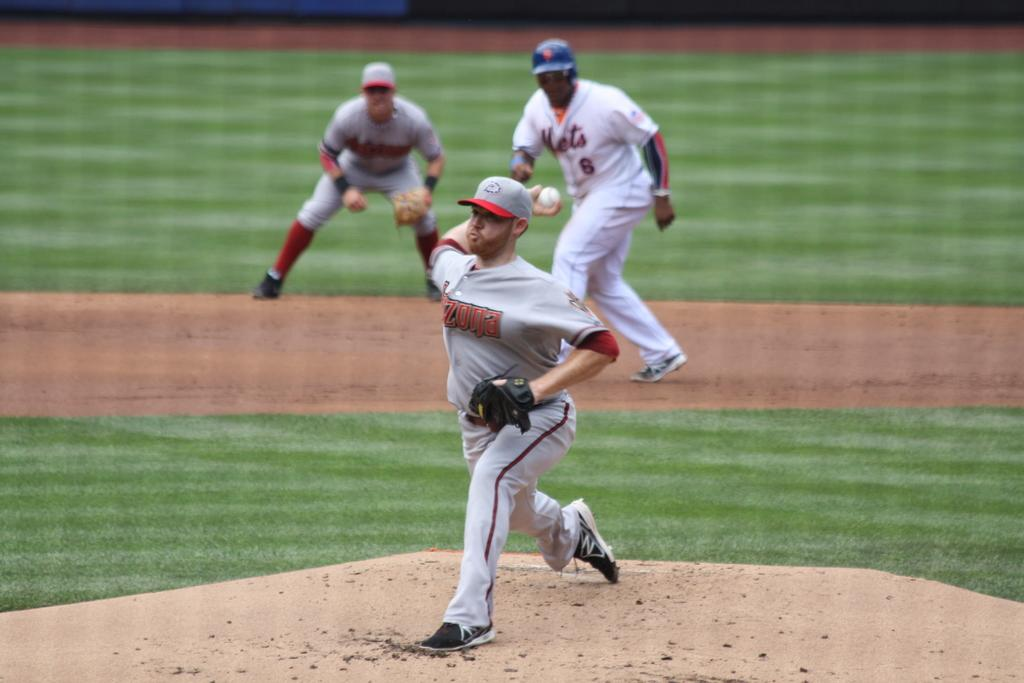<image>
Present a compact description of the photo's key features. Baseball pitcher swinging his arm to throw the ball and is on team Arizona. 